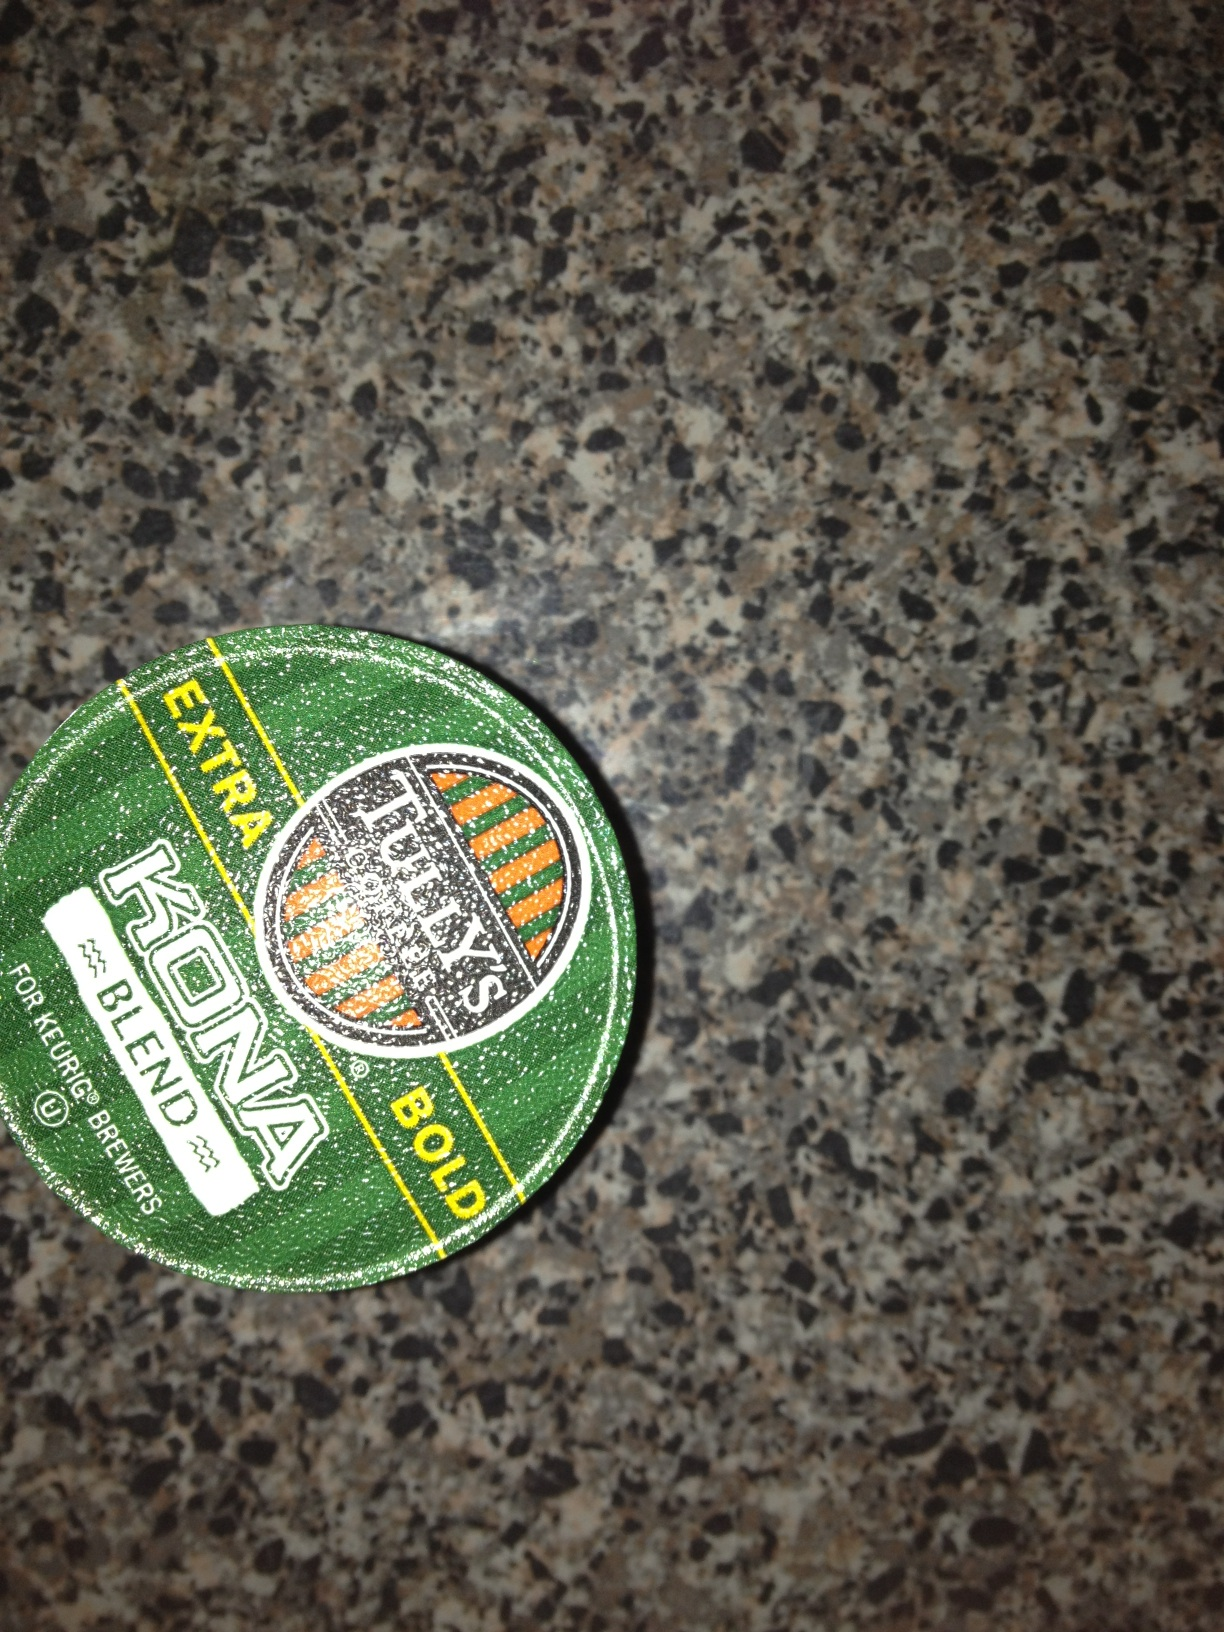How can I best enjoy this kind of coffee? Enjoying Tully's Extra Bold Kona Blend coffee is best done by brewing it with a Keurig or similar single-serve coffee machine. For an optimal experience, serve it black or with a small amount of milk to appreciate its strong, bold flavors. A medium grind is also recommended to fully extract its aromatic and flavor properties. What food pairings work well with this coffee? Tully's Extra Bold Kona Blend pairs wonderfully with sweet breakfast items like pancakes or waffles, as well as with rich desserts like chocolate cake or cheesecake. Its robust flavor also complements savory breakfast foods, such as bacon and eggs. 